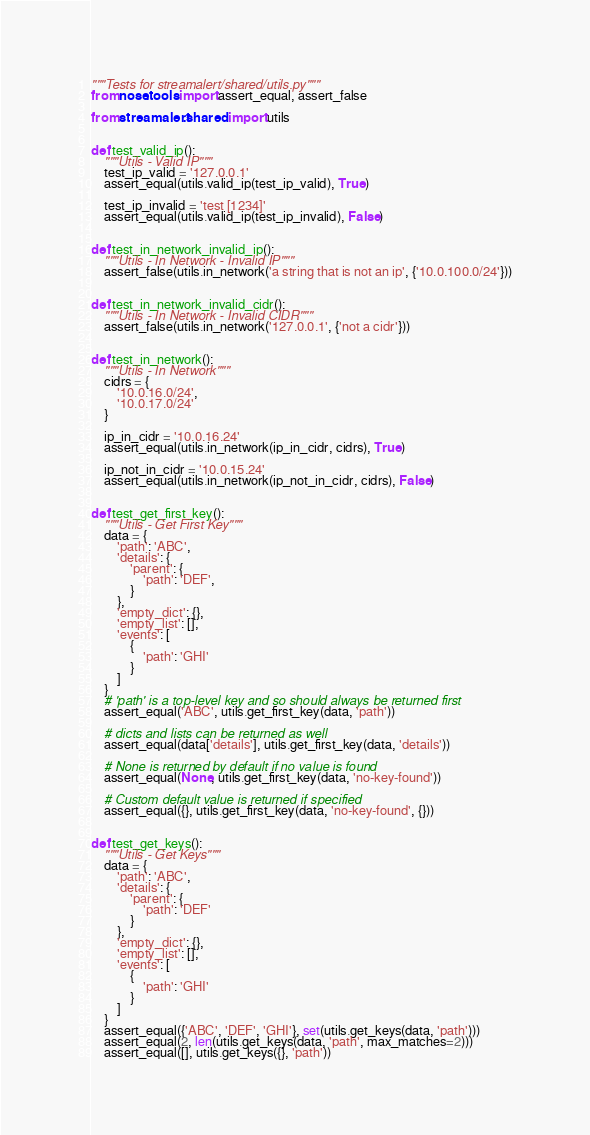Convert code to text. <code><loc_0><loc_0><loc_500><loc_500><_Python_>"""Tests for streamalert/shared/utils.py"""
from nose.tools import assert_equal, assert_false

from streamalert.shared import utils


def test_valid_ip():
    """Utils - Valid IP"""
    test_ip_valid = '127.0.0.1'
    assert_equal(utils.valid_ip(test_ip_valid), True)

    test_ip_invalid = 'test [1234]'
    assert_equal(utils.valid_ip(test_ip_invalid), False)


def test_in_network_invalid_ip():
    """Utils - In Network - Invalid IP"""
    assert_false(utils.in_network('a string that is not an ip', {'10.0.100.0/24'}))


def test_in_network_invalid_cidr():
    """Utils - In Network - Invalid CIDR"""
    assert_false(utils.in_network('127.0.0.1', {'not a cidr'}))


def test_in_network():
    """Utils - In Network"""
    cidrs = {
        '10.0.16.0/24',
        '10.0.17.0/24'
    }

    ip_in_cidr = '10.0.16.24'
    assert_equal(utils.in_network(ip_in_cidr, cidrs), True)

    ip_not_in_cidr = '10.0.15.24'
    assert_equal(utils.in_network(ip_not_in_cidr, cidrs), False)


def test_get_first_key():
    """Utils - Get First Key"""
    data = {
        'path': 'ABC',
        'details': {
            'parent': {
                'path': 'DEF',
            }
        },
        'empty_dict': {},
        'empty_list': [],
        'events': [
            {
                'path': 'GHI'
            }
        ]
    }
    # 'path' is a top-level key and so should always be returned first
    assert_equal('ABC', utils.get_first_key(data, 'path'))

    # dicts and lists can be returned as well
    assert_equal(data['details'], utils.get_first_key(data, 'details'))

    # None is returned by default if no value is found
    assert_equal(None, utils.get_first_key(data, 'no-key-found'))

    # Custom default value is returned if specified
    assert_equal({}, utils.get_first_key(data, 'no-key-found', {}))


def test_get_keys():
    """Utils - Get Keys"""
    data = {
        'path': 'ABC',
        'details': {
            'parent': {
                'path': 'DEF'
            }
        },
        'empty_dict': {},
        'empty_list': [],
        'events': [
            {
                'path': 'GHI'
            }
        ]
    }
    assert_equal({'ABC', 'DEF', 'GHI'}, set(utils.get_keys(data, 'path')))
    assert_equal(2, len(utils.get_keys(data, 'path', max_matches=2)))
    assert_equal([], utils.get_keys({}, 'path'))
</code> 